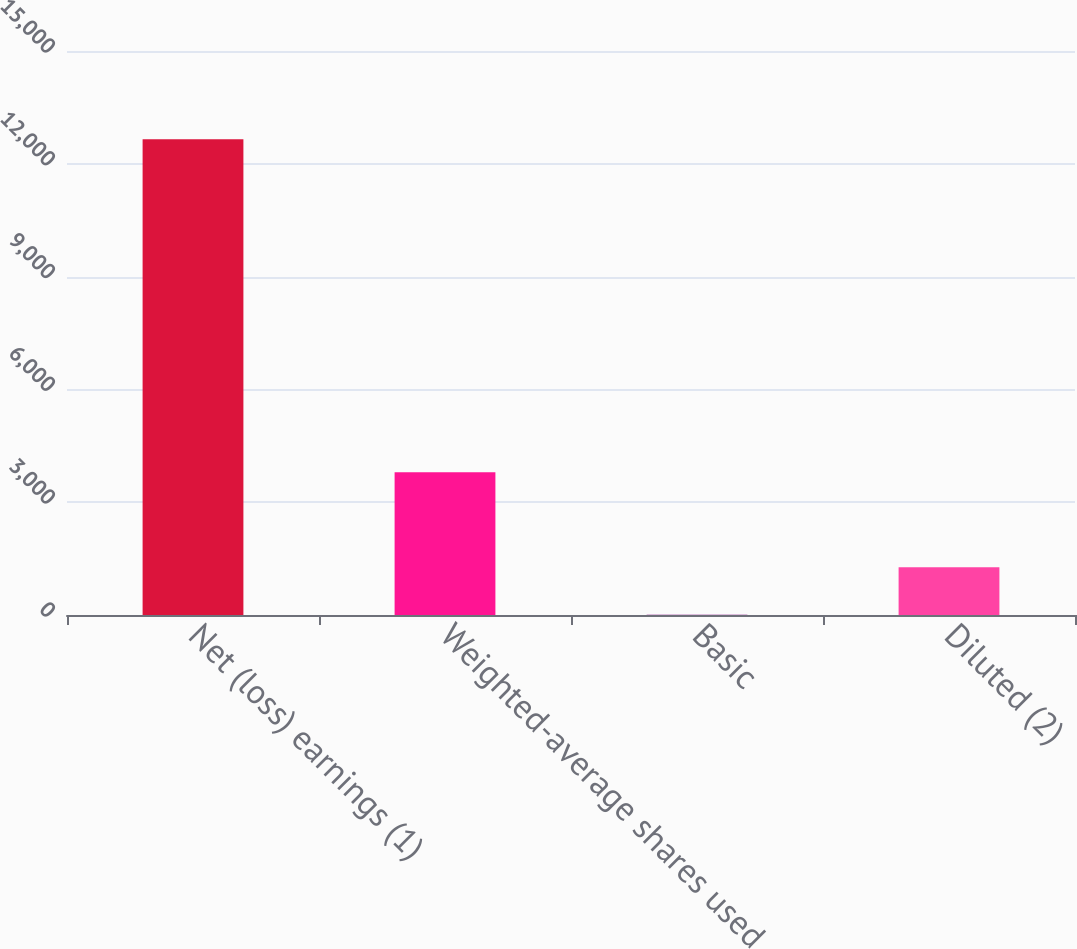<chart> <loc_0><loc_0><loc_500><loc_500><bar_chart><fcel>Net (loss) earnings (1)<fcel>Weighted-average shares used<fcel>Basic<fcel>Diluted (2)<nl><fcel>12650<fcel>3799.49<fcel>6.41<fcel>1270.77<nl></chart> 